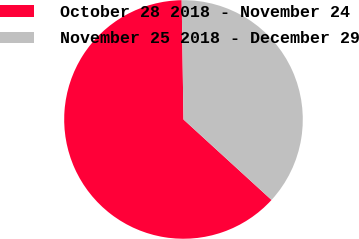Convert chart to OTSL. <chart><loc_0><loc_0><loc_500><loc_500><pie_chart><fcel>October 28 2018 - November 24<fcel>November 25 2018 - December 29<nl><fcel>62.97%<fcel>37.03%<nl></chart> 